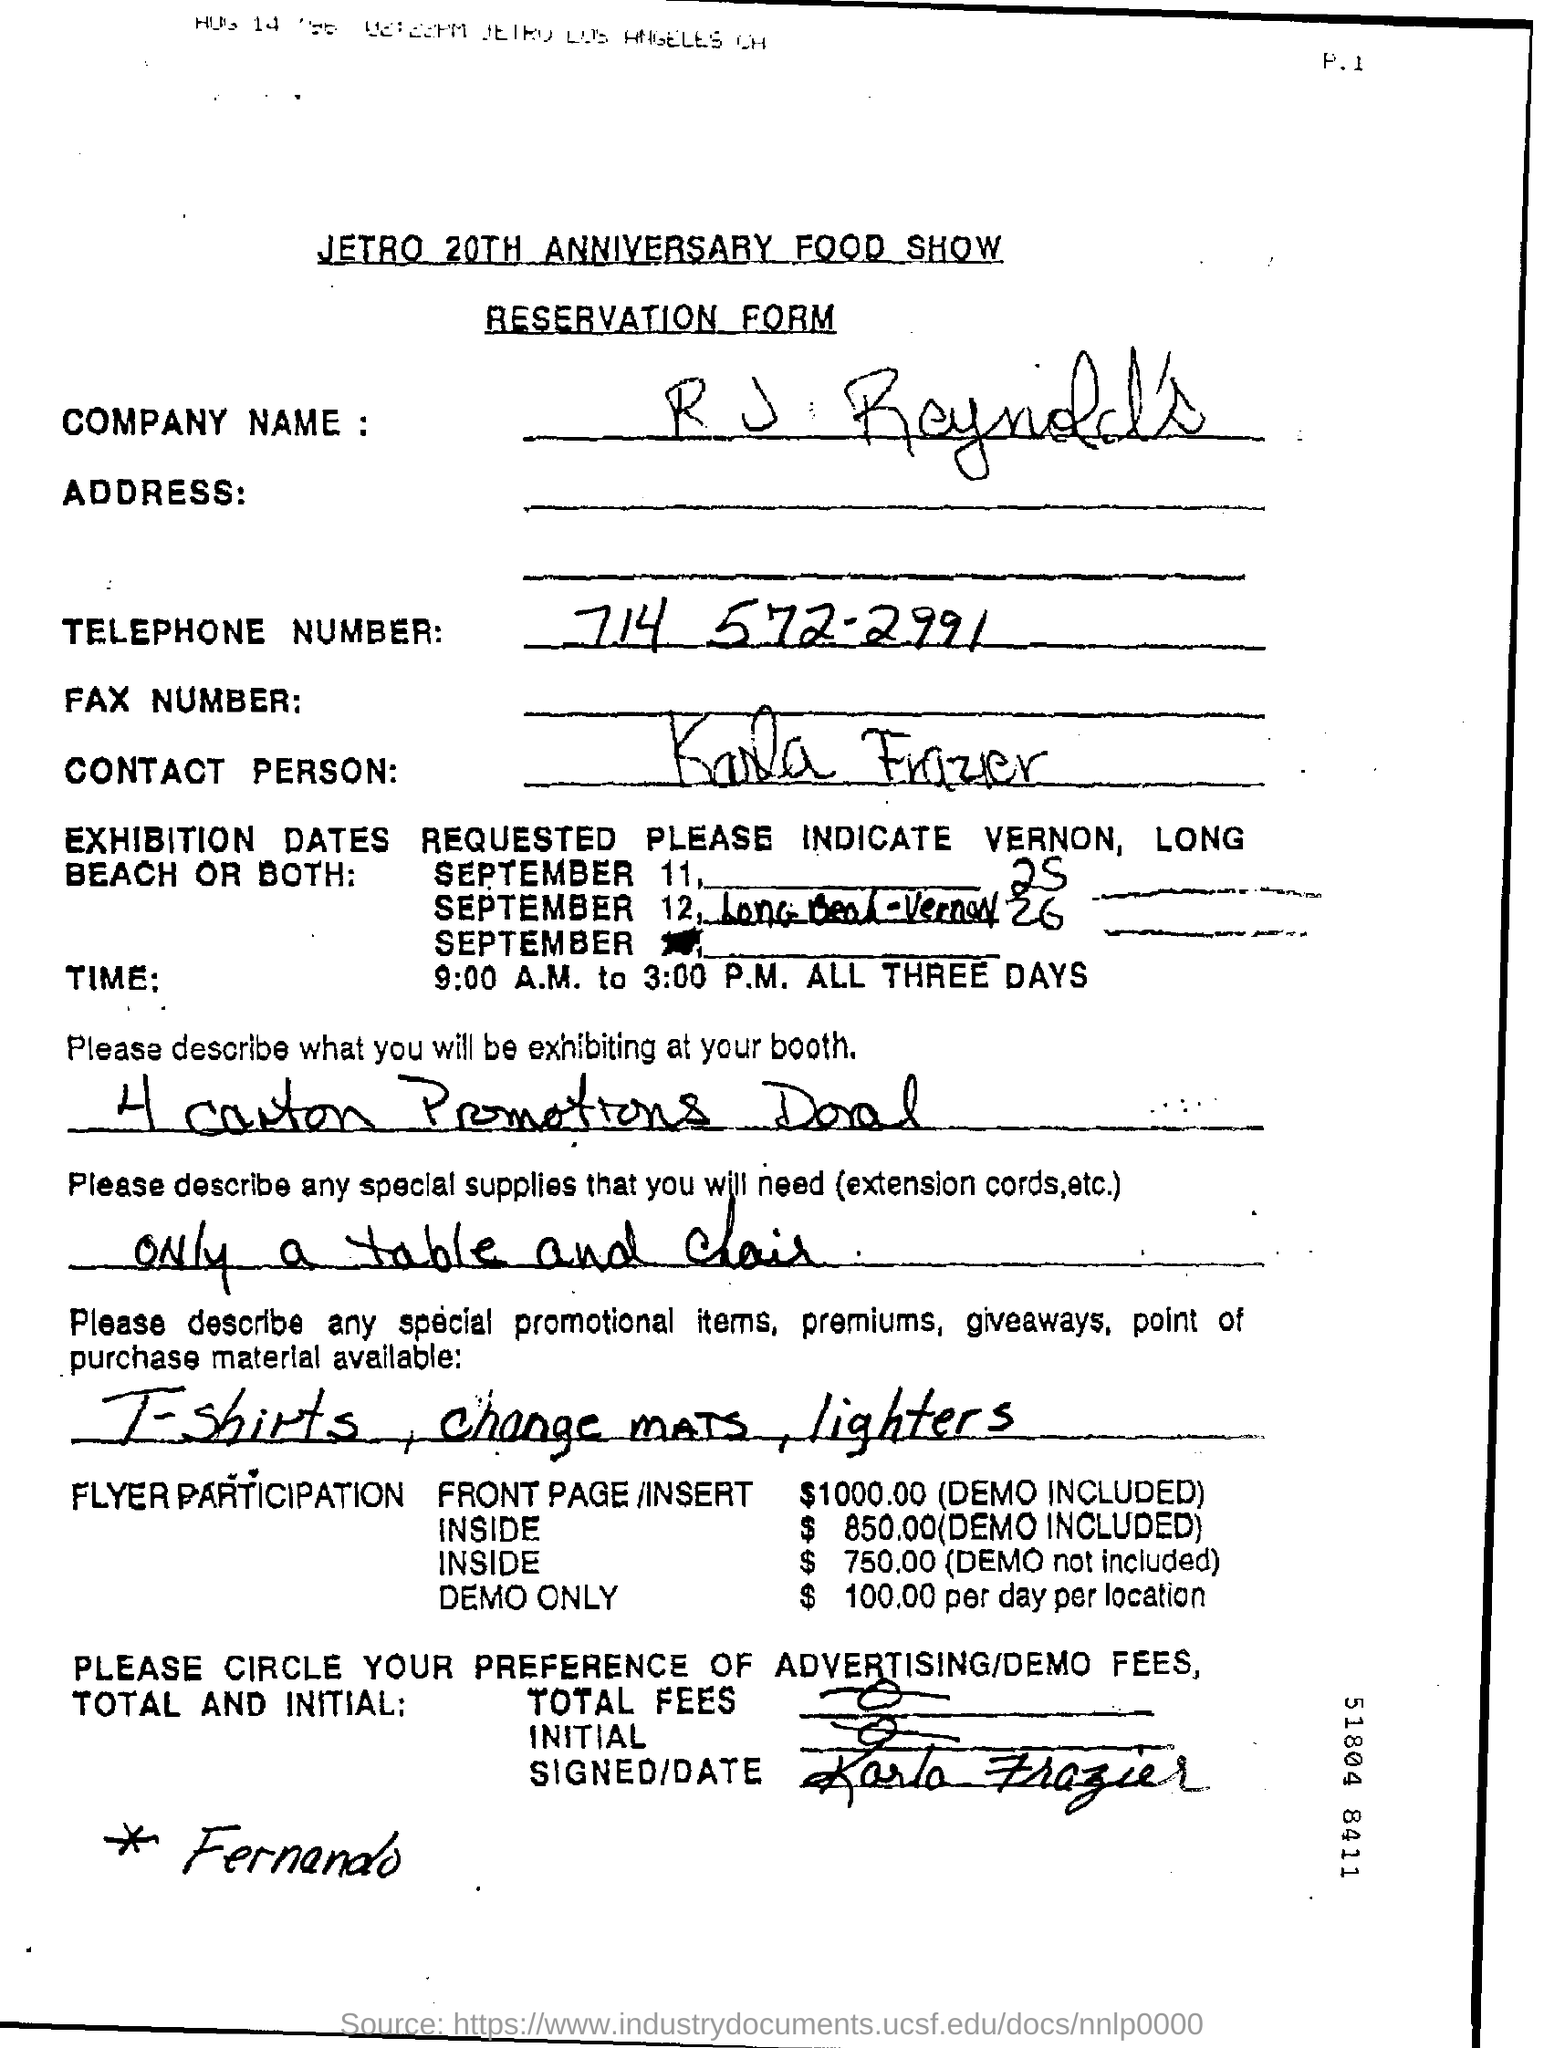What is the telephone no mentioned in the form?
Offer a very short reply. 714 572-2991. What is the cost of demo for flyer participation?
Your response must be concise. $ 100.00. When will the exhibition commence?
Provide a succinct answer. September 11. What are the timings of the exhibition?
Your answer should be compact. 9:00 A.M. to 3:00 P.M. 